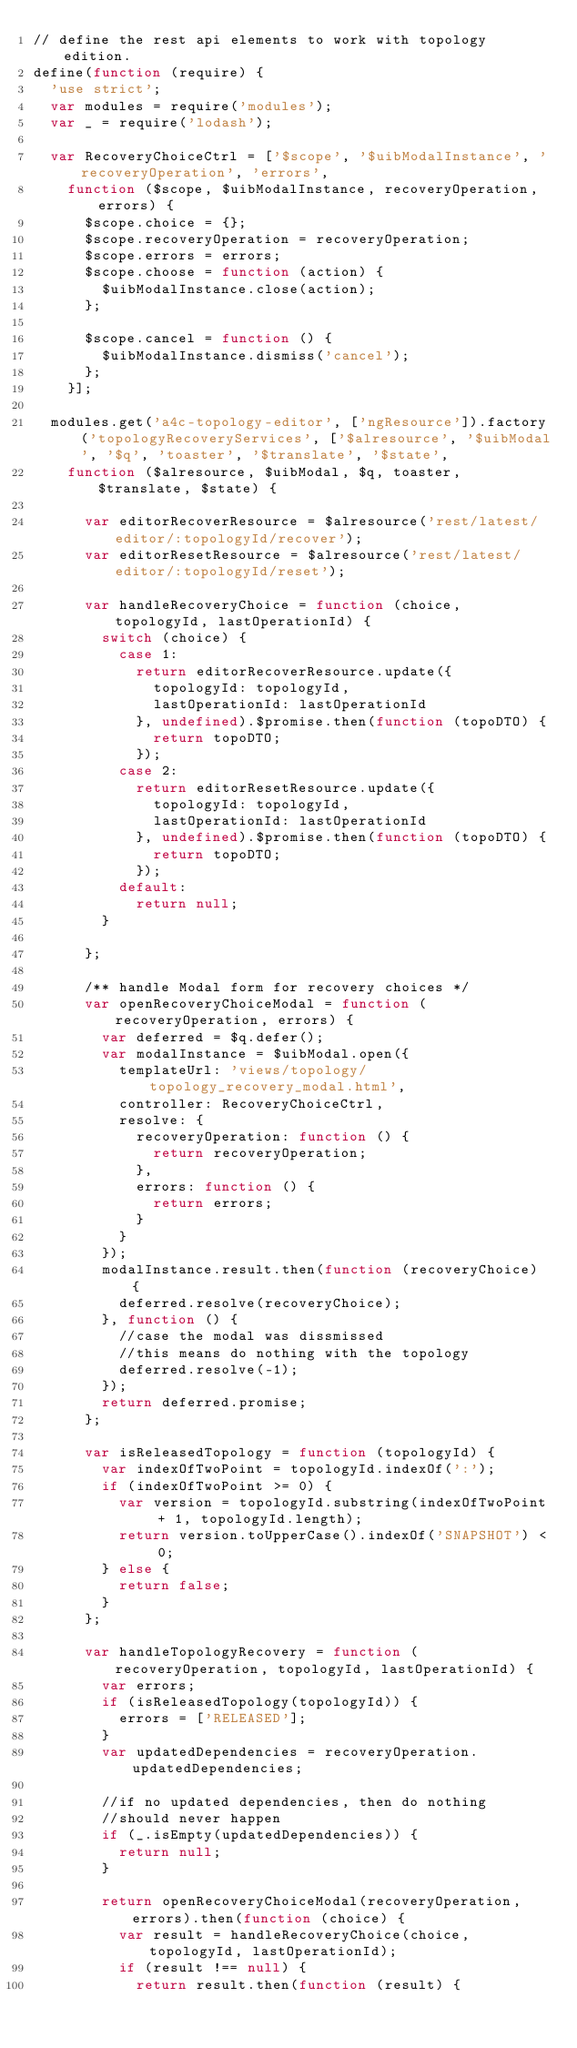<code> <loc_0><loc_0><loc_500><loc_500><_JavaScript_>// define the rest api elements to work with topology edition.
define(function (require) {
  'use strict';
  var modules = require('modules');
  var _ = require('lodash');

  var RecoveryChoiceCtrl = ['$scope', '$uibModalInstance', 'recoveryOperation', 'errors',
    function ($scope, $uibModalInstance, recoveryOperation, errors) {
      $scope.choice = {};
      $scope.recoveryOperation = recoveryOperation;
      $scope.errors = errors;
      $scope.choose = function (action) {
        $uibModalInstance.close(action);
      };

      $scope.cancel = function () {
        $uibModalInstance.dismiss('cancel');
      };
    }];

  modules.get('a4c-topology-editor', ['ngResource']).factory('topologyRecoveryServices', ['$alresource', '$uibModal', '$q', 'toaster', '$translate', '$state',
    function ($alresource, $uibModal, $q, toaster, $translate, $state) {

      var editorRecoverResource = $alresource('rest/latest/editor/:topologyId/recover');
      var editorResetResource = $alresource('rest/latest/editor/:topologyId/reset');

      var handleRecoveryChoice = function (choice, topologyId, lastOperationId) {
        switch (choice) {
          case 1:
            return editorRecoverResource.update({
              topologyId: topologyId,
              lastOperationId: lastOperationId
            }, undefined).$promise.then(function (topoDTO) {
              return topoDTO;
            });
          case 2:
            return editorResetResource.update({
              topologyId: topologyId,
              lastOperationId: lastOperationId
            }, undefined).$promise.then(function (topoDTO) {
              return topoDTO;
            });
          default:
            return null;
        }

      };

      /** handle Modal form for recovery choices */
      var openRecoveryChoiceModal = function (recoveryOperation, errors) {
        var deferred = $q.defer();
        var modalInstance = $uibModal.open({
          templateUrl: 'views/topology/topology_recovery_modal.html',
          controller: RecoveryChoiceCtrl,
          resolve: {
            recoveryOperation: function () {
              return recoveryOperation;
            },
            errors: function () {
              return errors;
            }
          }
        });
        modalInstance.result.then(function (recoveryChoice) {
          deferred.resolve(recoveryChoice);
        }, function () {
          //case the modal was dissmissed
          //this means do nothing with the topology
          deferred.resolve(-1);
        });
        return deferred.promise;
      };

      var isReleasedTopology = function (topologyId) {
        var indexOfTwoPoint = topologyId.indexOf(':');
        if (indexOfTwoPoint >= 0) {
          var version = topologyId.substring(indexOfTwoPoint + 1, topologyId.length);
          return version.toUpperCase().indexOf('SNAPSHOT') < 0;
        } else {
          return false;
        }
      };

      var handleTopologyRecovery = function (recoveryOperation, topologyId, lastOperationId) {
        var errors;
        if (isReleasedTopology(topologyId)) {
          errors = ['RELEASED'];
        }
        var updatedDependencies = recoveryOperation.updatedDependencies;

        //if no updated dependencies, then do nothing
        //should never happen
        if (_.isEmpty(updatedDependencies)) {
          return null;
        }

        return openRecoveryChoiceModal(recoveryOperation, errors).then(function (choice) {
          var result = handleRecoveryChoice(choice, topologyId, lastOperationId);
          if (result !== null) {
            return result.then(function (result) {</code> 